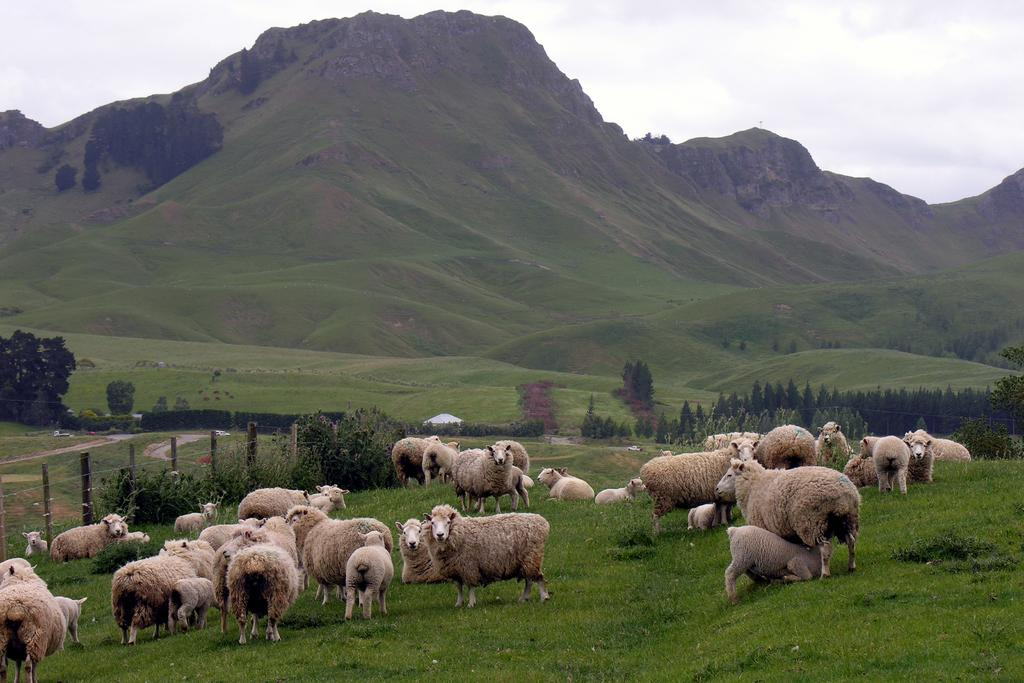What animals can be seen on the hill in the image? There are sheep on a hill in the image. What type of vegetation covers the hill? The hill has grass on it. What can be seen in the background of the image? There is a fence, plants, trees, and mountains visible in the background. What is present in the sky in the image? Clouds are in the sky in the image. How many clams are visible on the hill in the image? There are no clams present in the image; it features sheep on a hill. What type of cows can be seen grazing in the background of the image? There are no cows present in the image; it features a fence, plants, trees, and mountains in the background. 